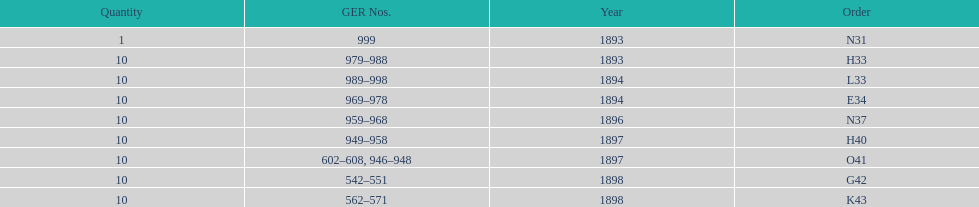Which had more ger numbers, 1898 or 1893? 1898. 